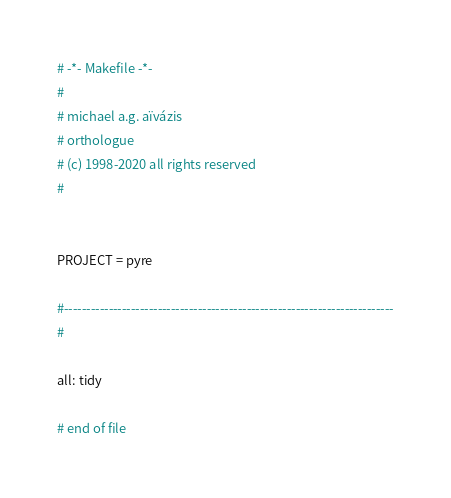<code> <loc_0><loc_0><loc_500><loc_500><_ObjectiveC_># -*- Makefile -*-
#
# michael a.g. aïvázis
# orthologue
# (c) 1998-2020 all rights reserved
#


PROJECT = pyre

#--------------------------------------------------------------------------
#

all: tidy

# end of file
</code> 